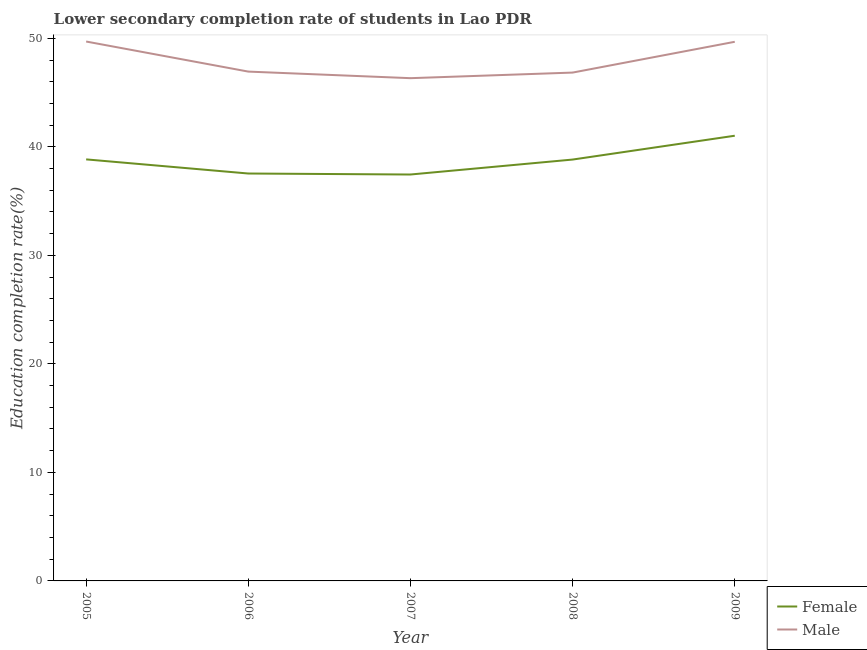How many different coloured lines are there?
Your answer should be very brief. 2. Does the line corresponding to education completion rate of male students intersect with the line corresponding to education completion rate of female students?
Offer a very short reply. No. What is the education completion rate of female students in 2005?
Provide a short and direct response. 38.84. Across all years, what is the maximum education completion rate of female students?
Offer a terse response. 41.02. Across all years, what is the minimum education completion rate of female students?
Your answer should be very brief. 37.45. In which year was the education completion rate of female students maximum?
Your answer should be compact. 2009. What is the total education completion rate of female students in the graph?
Ensure brevity in your answer.  193.69. What is the difference between the education completion rate of male students in 2005 and that in 2007?
Your answer should be compact. 3.38. What is the difference between the education completion rate of female students in 2009 and the education completion rate of male students in 2007?
Your answer should be very brief. -5.3. What is the average education completion rate of female students per year?
Offer a very short reply. 38.74. In the year 2005, what is the difference between the education completion rate of female students and education completion rate of male students?
Your response must be concise. -10.86. What is the ratio of the education completion rate of female students in 2005 to that in 2009?
Keep it short and to the point. 0.95. Is the education completion rate of male students in 2006 less than that in 2008?
Offer a terse response. No. Is the difference between the education completion rate of male students in 2005 and 2007 greater than the difference between the education completion rate of female students in 2005 and 2007?
Your response must be concise. Yes. What is the difference between the highest and the second highest education completion rate of female students?
Your response must be concise. 2.18. What is the difference between the highest and the lowest education completion rate of male students?
Your answer should be very brief. 3.38. In how many years, is the education completion rate of male students greater than the average education completion rate of male students taken over all years?
Offer a terse response. 2. Is the education completion rate of male students strictly greater than the education completion rate of female students over the years?
Provide a short and direct response. Yes. Is the education completion rate of female students strictly less than the education completion rate of male students over the years?
Your response must be concise. Yes. How many lines are there?
Provide a short and direct response. 2. What is the difference between two consecutive major ticks on the Y-axis?
Offer a very short reply. 10. Does the graph contain any zero values?
Your answer should be compact. No. How many legend labels are there?
Ensure brevity in your answer.  2. How are the legend labels stacked?
Provide a succinct answer. Vertical. What is the title of the graph?
Make the answer very short. Lower secondary completion rate of students in Lao PDR. Does "Drinking water services" appear as one of the legend labels in the graph?
Your answer should be very brief. No. What is the label or title of the X-axis?
Give a very brief answer. Year. What is the label or title of the Y-axis?
Offer a very short reply. Education completion rate(%). What is the Education completion rate(%) in Female in 2005?
Ensure brevity in your answer.  38.84. What is the Education completion rate(%) in Male in 2005?
Make the answer very short. 49.7. What is the Education completion rate(%) in Female in 2006?
Ensure brevity in your answer.  37.54. What is the Education completion rate(%) in Male in 2006?
Your answer should be very brief. 46.93. What is the Education completion rate(%) in Female in 2007?
Ensure brevity in your answer.  37.45. What is the Education completion rate(%) in Male in 2007?
Your answer should be very brief. 46.33. What is the Education completion rate(%) in Female in 2008?
Provide a succinct answer. 38.83. What is the Education completion rate(%) in Male in 2008?
Offer a terse response. 46.84. What is the Education completion rate(%) in Female in 2009?
Ensure brevity in your answer.  41.02. What is the Education completion rate(%) in Male in 2009?
Keep it short and to the point. 49.68. Across all years, what is the maximum Education completion rate(%) in Female?
Give a very brief answer. 41.02. Across all years, what is the maximum Education completion rate(%) of Male?
Offer a very short reply. 49.7. Across all years, what is the minimum Education completion rate(%) of Female?
Keep it short and to the point. 37.45. Across all years, what is the minimum Education completion rate(%) of Male?
Ensure brevity in your answer.  46.33. What is the total Education completion rate(%) in Female in the graph?
Keep it short and to the point. 193.69. What is the total Education completion rate(%) in Male in the graph?
Provide a short and direct response. 239.49. What is the difference between the Education completion rate(%) of Female in 2005 and that in 2006?
Your response must be concise. 1.3. What is the difference between the Education completion rate(%) in Male in 2005 and that in 2006?
Keep it short and to the point. 2.77. What is the difference between the Education completion rate(%) in Female in 2005 and that in 2007?
Your answer should be very brief. 1.39. What is the difference between the Education completion rate(%) of Male in 2005 and that in 2007?
Provide a succinct answer. 3.38. What is the difference between the Education completion rate(%) in Female in 2005 and that in 2008?
Your answer should be compact. 0.02. What is the difference between the Education completion rate(%) in Male in 2005 and that in 2008?
Provide a short and direct response. 2.86. What is the difference between the Education completion rate(%) of Female in 2005 and that in 2009?
Make the answer very short. -2.18. What is the difference between the Education completion rate(%) in Male in 2005 and that in 2009?
Offer a terse response. 0.02. What is the difference between the Education completion rate(%) of Female in 2006 and that in 2007?
Your answer should be very brief. 0.09. What is the difference between the Education completion rate(%) of Male in 2006 and that in 2007?
Give a very brief answer. 0.61. What is the difference between the Education completion rate(%) in Female in 2006 and that in 2008?
Provide a short and direct response. -1.29. What is the difference between the Education completion rate(%) in Male in 2006 and that in 2008?
Offer a terse response. 0.09. What is the difference between the Education completion rate(%) of Female in 2006 and that in 2009?
Offer a terse response. -3.48. What is the difference between the Education completion rate(%) in Male in 2006 and that in 2009?
Keep it short and to the point. -2.75. What is the difference between the Education completion rate(%) in Female in 2007 and that in 2008?
Give a very brief answer. -1.38. What is the difference between the Education completion rate(%) in Male in 2007 and that in 2008?
Provide a short and direct response. -0.52. What is the difference between the Education completion rate(%) of Female in 2007 and that in 2009?
Offer a terse response. -3.57. What is the difference between the Education completion rate(%) of Male in 2007 and that in 2009?
Make the answer very short. -3.35. What is the difference between the Education completion rate(%) in Female in 2008 and that in 2009?
Give a very brief answer. -2.2. What is the difference between the Education completion rate(%) in Male in 2008 and that in 2009?
Offer a terse response. -2.84. What is the difference between the Education completion rate(%) of Female in 2005 and the Education completion rate(%) of Male in 2006?
Give a very brief answer. -8.09. What is the difference between the Education completion rate(%) in Female in 2005 and the Education completion rate(%) in Male in 2007?
Provide a succinct answer. -7.48. What is the difference between the Education completion rate(%) in Female in 2005 and the Education completion rate(%) in Male in 2008?
Provide a short and direct response. -8. What is the difference between the Education completion rate(%) of Female in 2005 and the Education completion rate(%) of Male in 2009?
Offer a very short reply. -10.84. What is the difference between the Education completion rate(%) in Female in 2006 and the Education completion rate(%) in Male in 2007?
Provide a succinct answer. -8.79. What is the difference between the Education completion rate(%) in Female in 2006 and the Education completion rate(%) in Male in 2008?
Give a very brief answer. -9.3. What is the difference between the Education completion rate(%) of Female in 2006 and the Education completion rate(%) of Male in 2009?
Offer a very short reply. -12.14. What is the difference between the Education completion rate(%) in Female in 2007 and the Education completion rate(%) in Male in 2008?
Give a very brief answer. -9.39. What is the difference between the Education completion rate(%) of Female in 2007 and the Education completion rate(%) of Male in 2009?
Your answer should be compact. -12.23. What is the difference between the Education completion rate(%) of Female in 2008 and the Education completion rate(%) of Male in 2009?
Offer a terse response. -10.85. What is the average Education completion rate(%) in Female per year?
Your answer should be compact. 38.74. What is the average Education completion rate(%) of Male per year?
Provide a short and direct response. 47.9. In the year 2005, what is the difference between the Education completion rate(%) in Female and Education completion rate(%) in Male?
Your answer should be compact. -10.86. In the year 2006, what is the difference between the Education completion rate(%) in Female and Education completion rate(%) in Male?
Your answer should be compact. -9.39. In the year 2007, what is the difference between the Education completion rate(%) in Female and Education completion rate(%) in Male?
Ensure brevity in your answer.  -8.88. In the year 2008, what is the difference between the Education completion rate(%) of Female and Education completion rate(%) of Male?
Your answer should be compact. -8.01. In the year 2009, what is the difference between the Education completion rate(%) of Female and Education completion rate(%) of Male?
Offer a very short reply. -8.66. What is the ratio of the Education completion rate(%) in Female in 2005 to that in 2006?
Provide a short and direct response. 1.03. What is the ratio of the Education completion rate(%) in Male in 2005 to that in 2006?
Give a very brief answer. 1.06. What is the ratio of the Education completion rate(%) of Female in 2005 to that in 2007?
Give a very brief answer. 1.04. What is the ratio of the Education completion rate(%) in Male in 2005 to that in 2007?
Give a very brief answer. 1.07. What is the ratio of the Education completion rate(%) of Female in 2005 to that in 2008?
Your answer should be compact. 1. What is the ratio of the Education completion rate(%) in Male in 2005 to that in 2008?
Give a very brief answer. 1.06. What is the ratio of the Education completion rate(%) in Female in 2005 to that in 2009?
Ensure brevity in your answer.  0.95. What is the ratio of the Education completion rate(%) of Male in 2005 to that in 2009?
Provide a short and direct response. 1. What is the ratio of the Education completion rate(%) in Male in 2006 to that in 2007?
Your response must be concise. 1.01. What is the ratio of the Education completion rate(%) in Female in 2006 to that in 2008?
Provide a succinct answer. 0.97. What is the ratio of the Education completion rate(%) in Male in 2006 to that in 2008?
Your response must be concise. 1. What is the ratio of the Education completion rate(%) in Female in 2006 to that in 2009?
Ensure brevity in your answer.  0.92. What is the ratio of the Education completion rate(%) of Male in 2006 to that in 2009?
Your response must be concise. 0.94. What is the ratio of the Education completion rate(%) in Female in 2007 to that in 2008?
Keep it short and to the point. 0.96. What is the ratio of the Education completion rate(%) in Male in 2007 to that in 2008?
Offer a terse response. 0.99. What is the ratio of the Education completion rate(%) in Female in 2007 to that in 2009?
Your answer should be compact. 0.91. What is the ratio of the Education completion rate(%) of Male in 2007 to that in 2009?
Ensure brevity in your answer.  0.93. What is the ratio of the Education completion rate(%) in Female in 2008 to that in 2009?
Offer a very short reply. 0.95. What is the ratio of the Education completion rate(%) in Male in 2008 to that in 2009?
Your answer should be very brief. 0.94. What is the difference between the highest and the second highest Education completion rate(%) of Female?
Provide a succinct answer. 2.18. What is the difference between the highest and the second highest Education completion rate(%) in Male?
Give a very brief answer. 0.02. What is the difference between the highest and the lowest Education completion rate(%) of Female?
Your answer should be compact. 3.57. What is the difference between the highest and the lowest Education completion rate(%) of Male?
Offer a terse response. 3.38. 